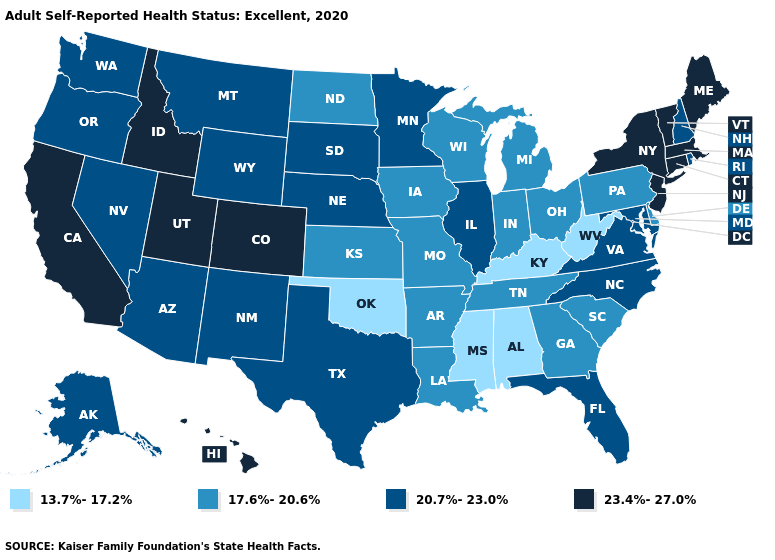Name the states that have a value in the range 13.7%-17.2%?
Quick response, please. Alabama, Kentucky, Mississippi, Oklahoma, West Virginia. Name the states that have a value in the range 13.7%-17.2%?
Concise answer only. Alabama, Kentucky, Mississippi, Oklahoma, West Virginia. What is the highest value in the USA?
Short answer required. 23.4%-27.0%. Name the states that have a value in the range 17.6%-20.6%?
Quick response, please. Arkansas, Delaware, Georgia, Indiana, Iowa, Kansas, Louisiana, Michigan, Missouri, North Dakota, Ohio, Pennsylvania, South Carolina, Tennessee, Wisconsin. Does Virginia have the highest value in the South?
Keep it brief. Yes. Does Wisconsin have the same value as Utah?
Answer briefly. No. Which states have the highest value in the USA?
Answer briefly. California, Colorado, Connecticut, Hawaii, Idaho, Maine, Massachusetts, New Jersey, New York, Utah, Vermont. Does New Mexico have the same value as Delaware?
Be succinct. No. Name the states that have a value in the range 17.6%-20.6%?
Concise answer only. Arkansas, Delaware, Georgia, Indiana, Iowa, Kansas, Louisiana, Michigan, Missouri, North Dakota, Ohio, Pennsylvania, South Carolina, Tennessee, Wisconsin. What is the lowest value in states that border Iowa?
Keep it brief. 17.6%-20.6%. Does the map have missing data?
Quick response, please. No. Name the states that have a value in the range 23.4%-27.0%?
Quick response, please. California, Colorado, Connecticut, Hawaii, Idaho, Maine, Massachusetts, New Jersey, New York, Utah, Vermont. What is the highest value in the Northeast ?
Quick response, please. 23.4%-27.0%. Is the legend a continuous bar?
Be succinct. No. 